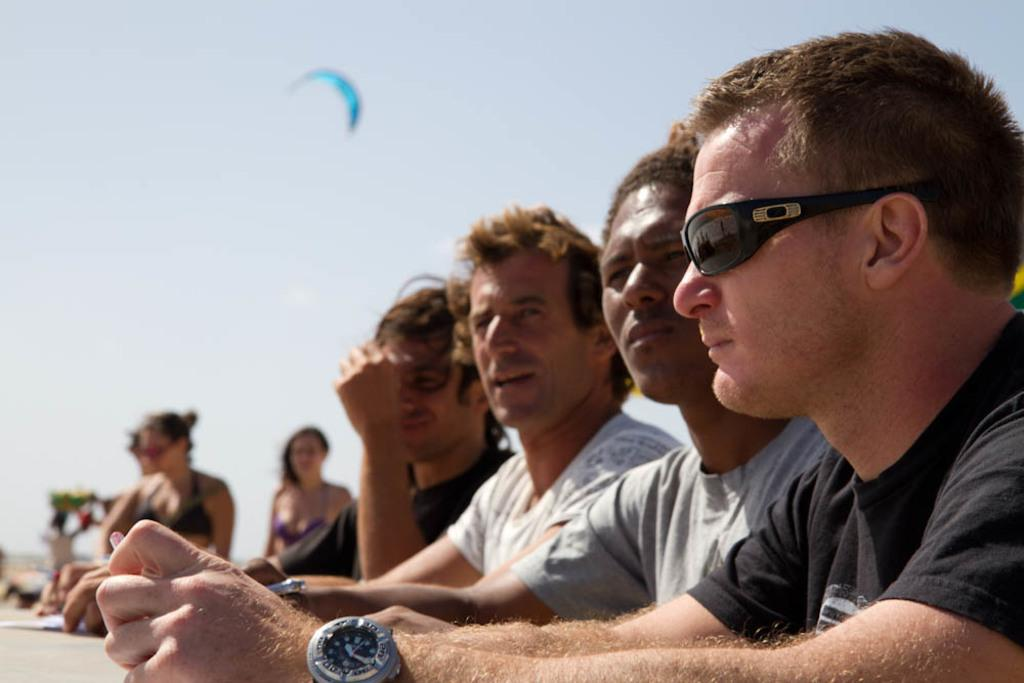How many men are in the image? There are four men in the image. What are the men wearing? The men are wearing T-shirts. Can you describe the actions of one of the men? One of the men appears to be speaking. What can be seen on the left side of the image? There are two women on the left side of the image. What is visible in the sky in the image? There are clouds in the sky. What type of frame is being used to hold the apples in the image? There are no apples present in the image, so there is no frame holding them. What kind of quilt is being used to cover the men in the image? There is no quilt visible in the image; the men are wearing T-shirts. 